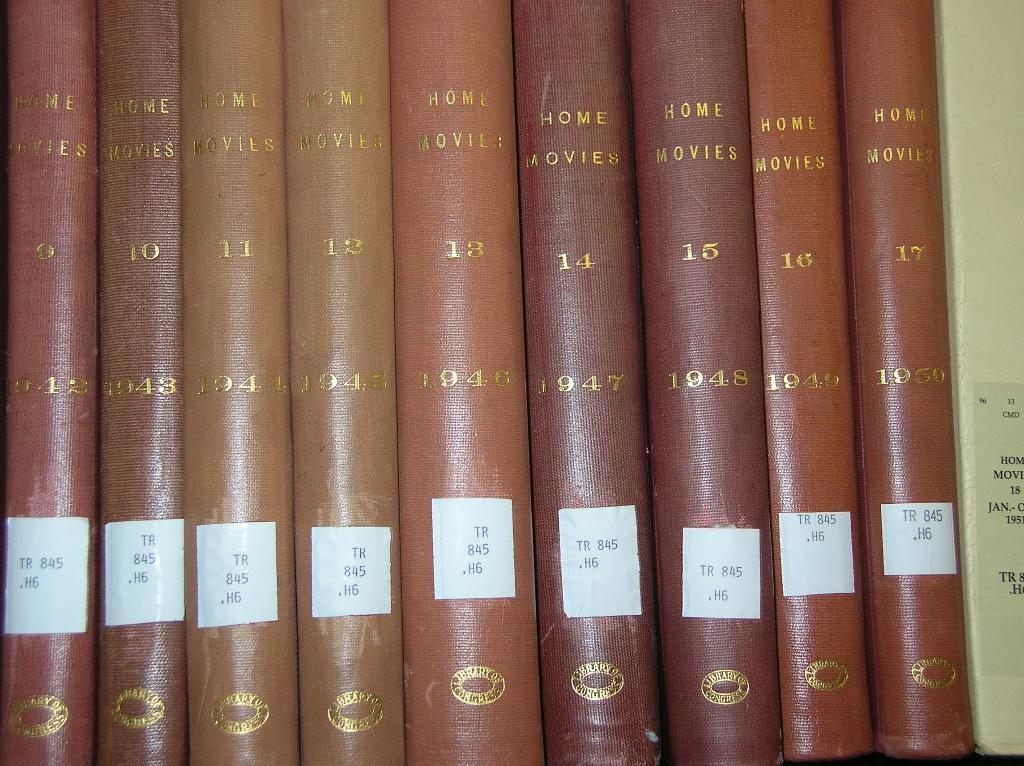<image>
Describe the image concisely. A collection of books entitled "Home Movies" from the 1940' 